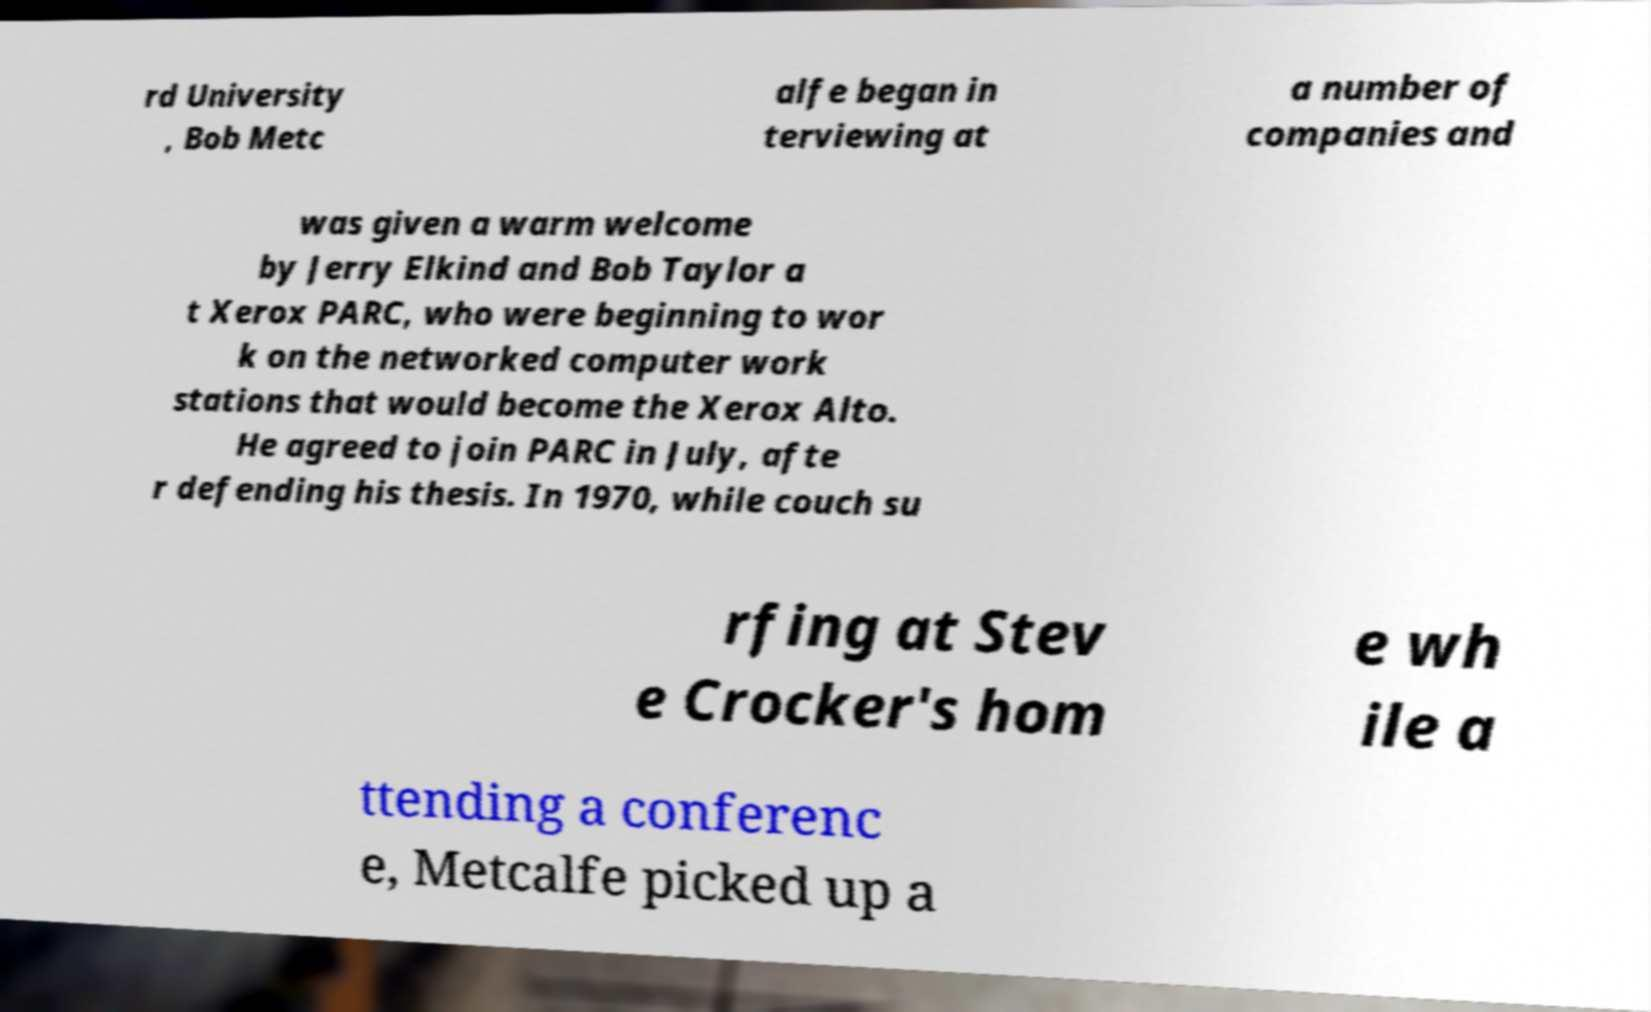For documentation purposes, I need the text within this image transcribed. Could you provide that? rd University , Bob Metc alfe began in terviewing at a number of companies and was given a warm welcome by Jerry Elkind and Bob Taylor a t Xerox PARC, who were beginning to wor k on the networked computer work stations that would become the Xerox Alto. He agreed to join PARC in July, afte r defending his thesis. In 1970, while couch su rfing at Stev e Crocker's hom e wh ile a ttending a conferenc e, Metcalfe picked up a 